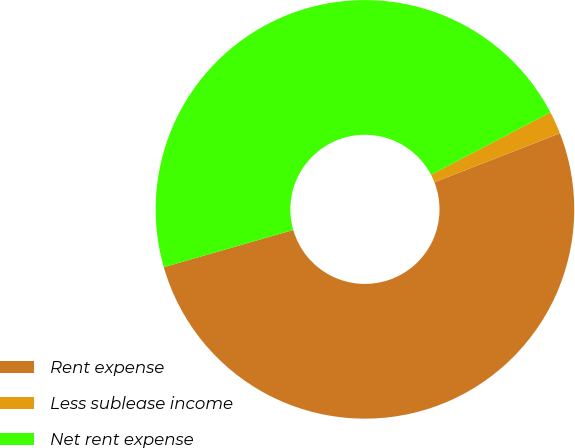Convert chart to OTSL. <chart><loc_0><loc_0><loc_500><loc_500><pie_chart><fcel>Rent expense<fcel>Less sublease income<fcel>Net rent expense<nl><fcel>51.47%<fcel>1.75%<fcel>46.79%<nl></chart> 